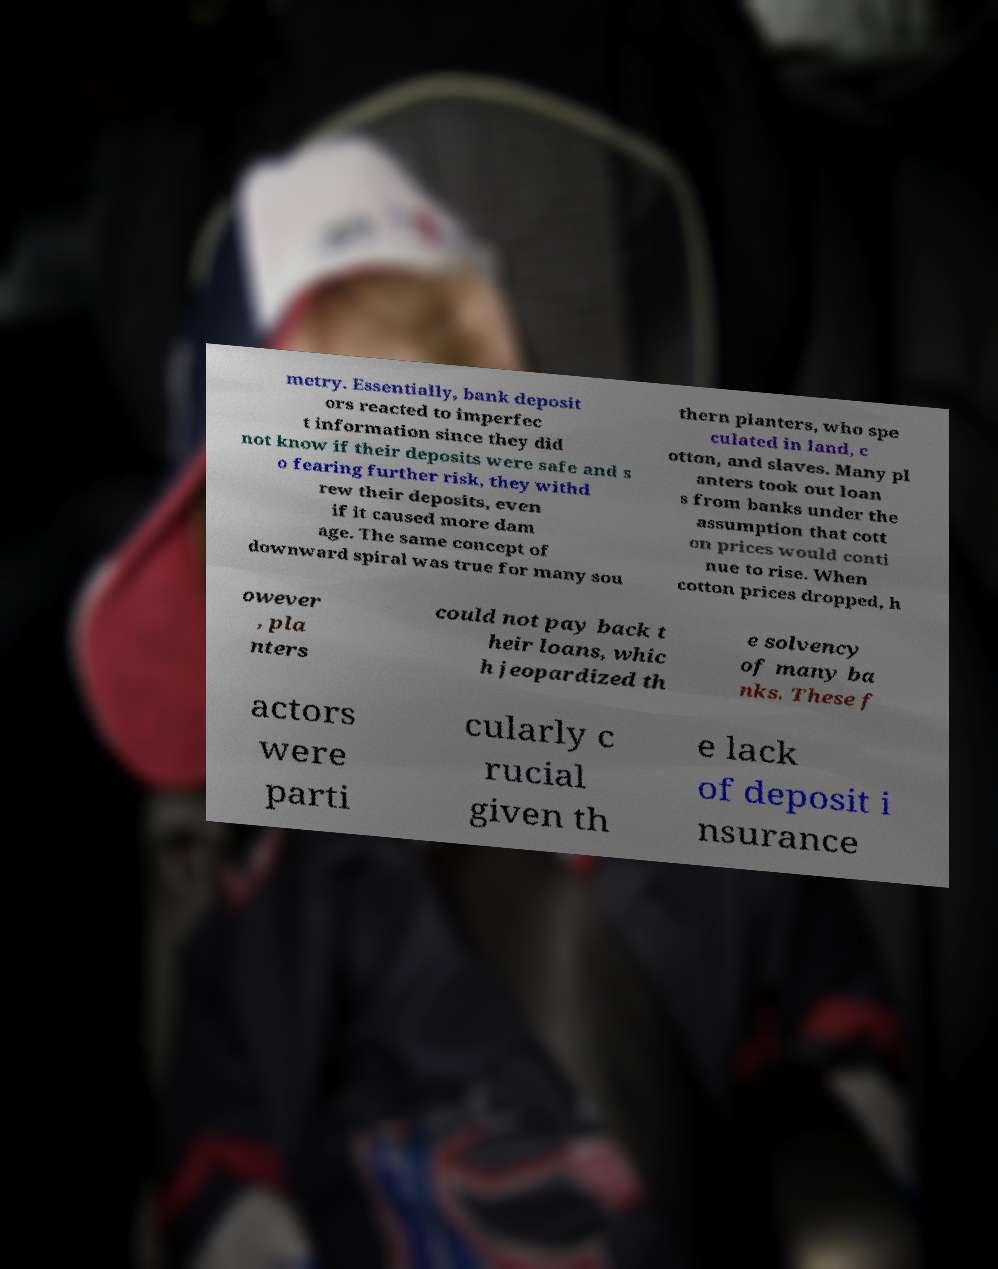For documentation purposes, I need the text within this image transcribed. Could you provide that? metry. Essentially, bank deposit ors reacted to imperfec t information since they did not know if their deposits were safe and s o fearing further risk, they withd rew their deposits, even if it caused more dam age. The same concept of downward spiral was true for many sou thern planters, who spe culated in land, c otton, and slaves. Many pl anters took out loan s from banks under the assumption that cott on prices would conti nue to rise. When cotton prices dropped, h owever , pla nters could not pay back t heir loans, whic h jeopardized th e solvency of many ba nks. These f actors were parti cularly c rucial given th e lack of deposit i nsurance 